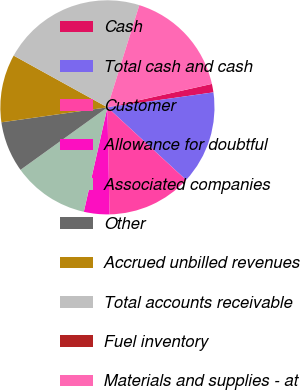<chart> <loc_0><loc_0><loc_500><loc_500><pie_chart><fcel>Cash<fcel>Total cash and cash<fcel>Customer<fcel>Allowance for doubtful<fcel>Associated companies<fcel>Other<fcel>Accrued unbilled revenues<fcel>Total accounts receivable<fcel>Fuel inventory<fcel>Materials and supplies - at<nl><fcel>1.28%<fcel>14.1%<fcel>12.82%<fcel>3.85%<fcel>11.54%<fcel>7.69%<fcel>10.26%<fcel>21.79%<fcel>0.0%<fcel>16.67%<nl></chart> 